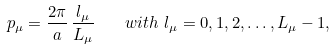Convert formula to latex. <formula><loc_0><loc_0><loc_500><loc_500>p _ { \mu } = \frac { 2 \pi } { a } \, \frac { l _ { \mu } } { L _ { \mu } } \quad w i t h \ l _ { \mu } = 0 , 1 , 2 , \dots , L _ { \mu } - 1 ,</formula> 